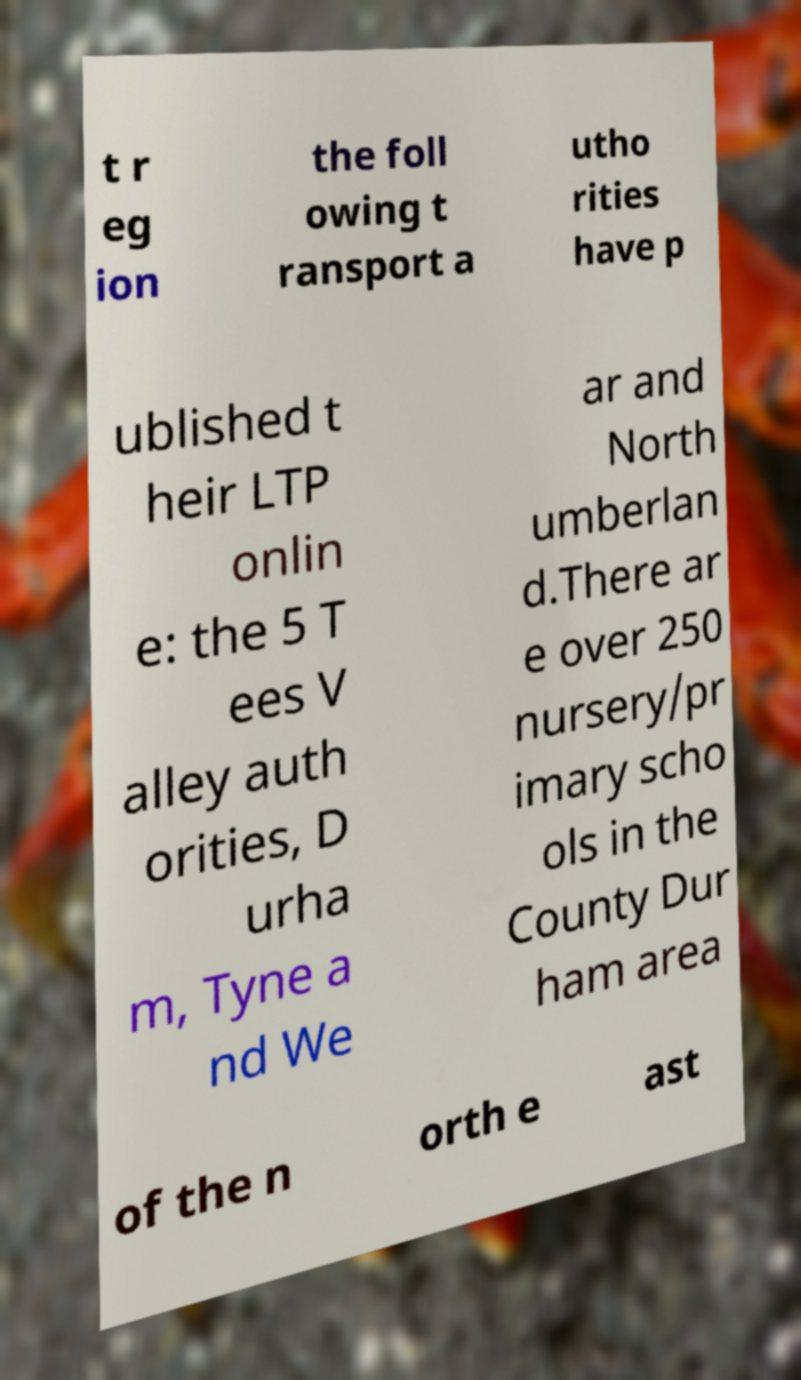Could you extract and type out the text from this image? t r eg ion the foll owing t ransport a utho rities have p ublished t heir LTP onlin e: the 5 T ees V alley auth orities, D urha m, Tyne a nd We ar and North umberlan d.There ar e over 250 nursery/pr imary scho ols in the County Dur ham area of the n orth e ast 